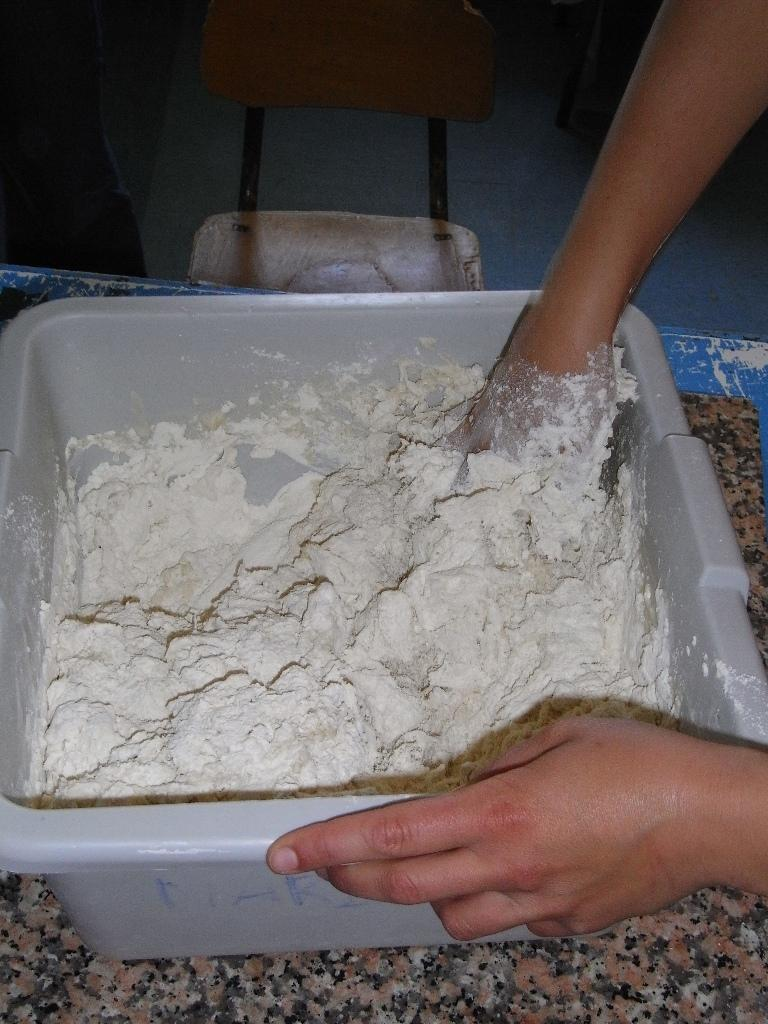What is in the big plastic bowl in the image? There is powder in the bowl. What is the person in the image doing with the powder? The person is handling the powder in the bowl. Where is the bowl located in the image? The bowl is placed on the floor. What is behind the bowl in the image? There is a chair behind the bowl. What books are the person reading while handling the powder in the image? There are no books present in the image; the person is handling powder in a big plastic bowl. 